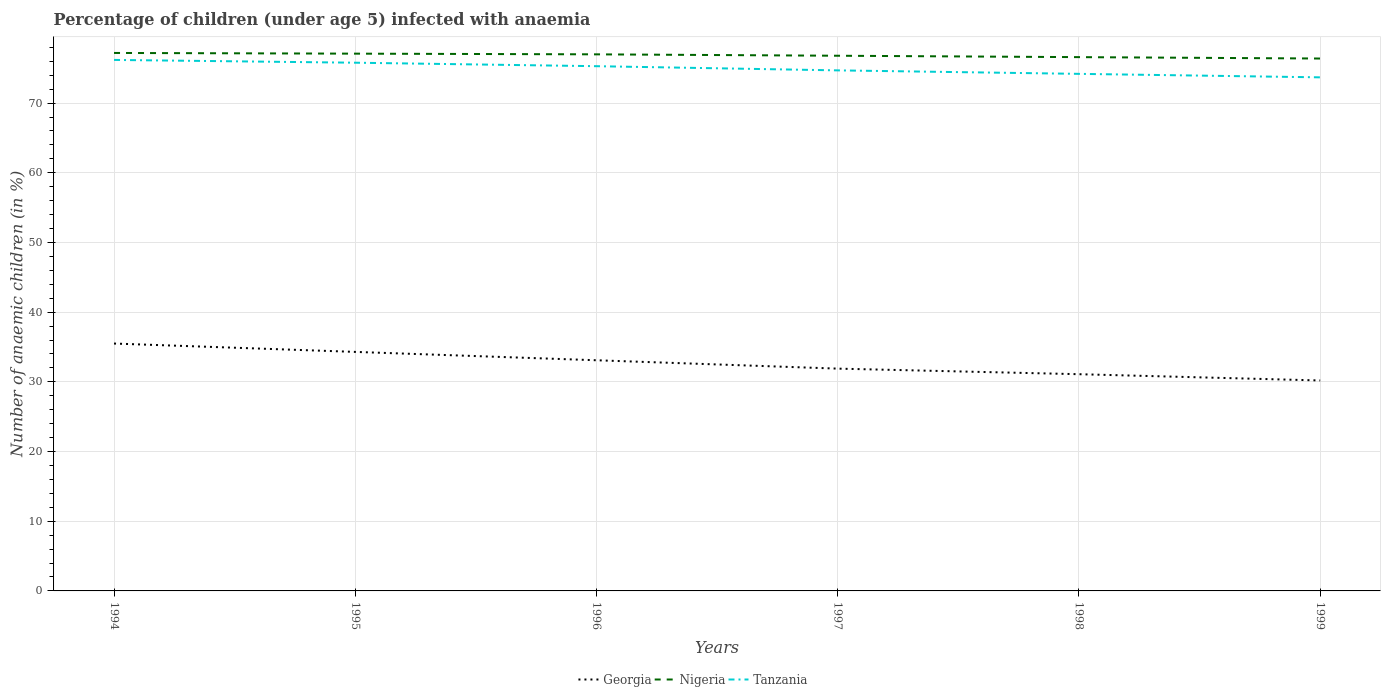How many different coloured lines are there?
Offer a very short reply. 3. Does the line corresponding to Nigeria intersect with the line corresponding to Georgia?
Your answer should be compact. No. Across all years, what is the maximum percentage of children infected with anaemia in in Nigeria?
Ensure brevity in your answer.  76.4. In which year was the percentage of children infected with anaemia in in Georgia maximum?
Make the answer very short. 1999. What is the total percentage of children infected with anaemia in in Nigeria in the graph?
Offer a terse response. 0.2. What is the difference between the highest and the second highest percentage of children infected with anaemia in in Nigeria?
Offer a very short reply. 0.8. What is the difference between the highest and the lowest percentage of children infected with anaemia in in Tanzania?
Offer a terse response. 3. How many lines are there?
Offer a terse response. 3. What is the difference between two consecutive major ticks on the Y-axis?
Your answer should be compact. 10. Are the values on the major ticks of Y-axis written in scientific E-notation?
Ensure brevity in your answer.  No. Where does the legend appear in the graph?
Make the answer very short. Bottom center. What is the title of the graph?
Provide a succinct answer. Percentage of children (under age 5) infected with anaemia. Does "Peru" appear as one of the legend labels in the graph?
Offer a very short reply. No. What is the label or title of the Y-axis?
Your response must be concise. Number of anaemic children (in %). What is the Number of anaemic children (in %) of Georgia in 1994?
Keep it short and to the point. 35.5. What is the Number of anaemic children (in %) of Nigeria in 1994?
Keep it short and to the point. 77.2. What is the Number of anaemic children (in %) of Tanzania in 1994?
Keep it short and to the point. 76.2. What is the Number of anaemic children (in %) in Georgia in 1995?
Your response must be concise. 34.3. What is the Number of anaemic children (in %) in Nigeria in 1995?
Give a very brief answer. 77.1. What is the Number of anaemic children (in %) in Tanzania in 1995?
Offer a very short reply. 75.8. What is the Number of anaemic children (in %) in Georgia in 1996?
Provide a short and direct response. 33.1. What is the Number of anaemic children (in %) of Nigeria in 1996?
Your answer should be compact. 77. What is the Number of anaemic children (in %) in Tanzania in 1996?
Your response must be concise. 75.3. What is the Number of anaemic children (in %) in Georgia in 1997?
Your answer should be very brief. 31.9. What is the Number of anaemic children (in %) of Nigeria in 1997?
Keep it short and to the point. 76.8. What is the Number of anaemic children (in %) in Tanzania in 1997?
Provide a short and direct response. 74.7. What is the Number of anaemic children (in %) in Georgia in 1998?
Make the answer very short. 31.1. What is the Number of anaemic children (in %) in Nigeria in 1998?
Make the answer very short. 76.6. What is the Number of anaemic children (in %) of Tanzania in 1998?
Provide a succinct answer. 74.2. What is the Number of anaemic children (in %) of Georgia in 1999?
Offer a very short reply. 30.2. What is the Number of anaemic children (in %) of Nigeria in 1999?
Provide a short and direct response. 76.4. What is the Number of anaemic children (in %) in Tanzania in 1999?
Your answer should be compact. 73.7. Across all years, what is the maximum Number of anaemic children (in %) of Georgia?
Make the answer very short. 35.5. Across all years, what is the maximum Number of anaemic children (in %) in Nigeria?
Offer a terse response. 77.2. Across all years, what is the maximum Number of anaemic children (in %) of Tanzania?
Give a very brief answer. 76.2. Across all years, what is the minimum Number of anaemic children (in %) of Georgia?
Your response must be concise. 30.2. Across all years, what is the minimum Number of anaemic children (in %) of Nigeria?
Make the answer very short. 76.4. Across all years, what is the minimum Number of anaemic children (in %) of Tanzania?
Offer a terse response. 73.7. What is the total Number of anaemic children (in %) of Georgia in the graph?
Make the answer very short. 196.1. What is the total Number of anaemic children (in %) of Nigeria in the graph?
Offer a very short reply. 461.1. What is the total Number of anaemic children (in %) in Tanzania in the graph?
Keep it short and to the point. 449.9. What is the difference between the Number of anaemic children (in %) of Georgia in 1994 and that in 1995?
Give a very brief answer. 1.2. What is the difference between the Number of anaemic children (in %) in Tanzania in 1994 and that in 1995?
Offer a terse response. 0.4. What is the difference between the Number of anaemic children (in %) of Georgia in 1994 and that in 1996?
Give a very brief answer. 2.4. What is the difference between the Number of anaemic children (in %) of Tanzania in 1994 and that in 1996?
Offer a terse response. 0.9. What is the difference between the Number of anaemic children (in %) in Nigeria in 1994 and that in 1998?
Provide a succinct answer. 0.6. What is the difference between the Number of anaemic children (in %) of Tanzania in 1994 and that in 1999?
Make the answer very short. 2.5. What is the difference between the Number of anaemic children (in %) of Nigeria in 1995 and that in 1996?
Ensure brevity in your answer.  0.1. What is the difference between the Number of anaemic children (in %) in Tanzania in 1995 and that in 1996?
Provide a succinct answer. 0.5. What is the difference between the Number of anaemic children (in %) in Tanzania in 1995 and that in 1997?
Your response must be concise. 1.1. What is the difference between the Number of anaemic children (in %) in Georgia in 1995 and that in 1998?
Give a very brief answer. 3.2. What is the difference between the Number of anaemic children (in %) of Georgia in 1995 and that in 1999?
Your answer should be very brief. 4.1. What is the difference between the Number of anaemic children (in %) in Nigeria in 1996 and that in 1997?
Give a very brief answer. 0.2. What is the difference between the Number of anaemic children (in %) of Tanzania in 1996 and that in 1997?
Offer a terse response. 0.6. What is the difference between the Number of anaemic children (in %) of Georgia in 1996 and that in 1998?
Provide a short and direct response. 2. What is the difference between the Number of anaemic children (in %) of Georgia in 1996 and that in 1999?
Your response must be concise. 2.9. What is the difference between the Number of anaemic children (in %) of Nigeria in 1996 and that in 1999?
Your answer should be very brief. 0.6. What is the difference between the Number of anaemic children (in %) in Tanzania in 1997 and that in 1998?
Make the answer very short. 0.5. What is the difference between the Number of anaemic children (in %) of Georgia in 1997 and that in 1999?
Offer a terse response. 1.7. What is the difference between the Number of anaemic children (in %) in Nigeria in 1997 and that in 1999?
Offer a terse response. 0.4. What is the difference between the Number of anaemic children (in %) of Tanzania in 1997 and that in 1999?
Your answer should be very brief. 1. What is the difference between the Number of anaemic children (in %) in Nigeria in 1998 and that in 1999?
Your answer should be compact. 0.2. What is the difference between the Number of anaemic children (in %) of Georgia in 1994 and the Number of anaemic children (in %) of Nigeria in 1995?
Offer a very short reply. -41.6. What is the difference between the Number of anaemic children (in %) of Georgia in 1994 and the Number of anaemic children (in %) of Tanzania in 1995?
Offer a very short reply. -40.3. What is the difference between the Number of anaemic children (in %) in Nigeria in 1994 and the Number of anaemic children (in %) in Tanzania in 1995?
Make the answer very short. 1.4. What is the difference between the Number of anaemic children (in %) of Georgia in 1994 and the Number of anaemic children (in %) of Nigeria in 1996?
Provide a short and direct response. -41.5. What is the difference between the Number of anaemic children (in %) in Georgia in 1994 and the Number of anaemic children (in %) in Tanzania in 1996?
Ensure brevity in your answer.  -39.8. What is the difference between the Number of anaemic children (in %) in Nigeria in 1994 and the Number of anaemic children (in %) in Tanzania in 1996?
Offer a terse response. 1.9. What is the difference between the Number of anaemic children (in %) in Georgia in 1994 and the Number of anaemic children (in %) in Nigeria in 1997?
Provide a short and direct response. -41.3. What is the difference between the Number of anaemic children (in %) of Georgia in 1994 and the Number of anaemic children (in %) of Tanzania in 1997?
Make the answer very short. -39.2. What is the difference between the Number of anaemic children (in %) in Nigeria in 1994 and the Number of anaemic children (in %) in Tanzania in 1997?
Your answer should be very brief. 2.5. What is the difference between the Number of anaemic children (in %) of Georgia in 1994 and the Number of anaemic children (in %) of Nigeria in 1998?
Your answer should be compact. -41.1. What is the difference between the Number of anaemic children (in %) in Georgia in 1994 and the Number of anaemic children (in %) in Tanzania in 1998?
Your response must be concise. -38.7. What is the difference between the Number of anaemic children (in %) of Georgia in 1994 and the Number of anaemic children (in %) of Nigeria in 1999?
Offer a terse response. -40.9. What is the difference between the Number of anaemic children (in %) of Georgia in 1994 and the Number of anaemic children (in %) of Tanzania in 1999?
Keep it short and to the point. -38.2. What is the difference between the Number of anaemic children (in %) in Georgia in 1995 and the Number of anaemic children (in %) in Nigeria in 1996?
Provide a short and direct response. -42.7. What is the difference between the Number of anaemic children (in %) of Georgia in 1995 and the Number of anaemic children (in %) of Tanzania in 1996?
Offer a terse response. -41. What is the difference between the Number of anaemic children (in %) in Georgia in 1995 and the Number of anaemic children (in %) in Nigeria in 1997?
Ensure brevity in your answer.  -42.5. What is the difference between the Number of anaemic children (in %) of Georgia in 1995 and the Number of anaemic children (in %) of Tanzania in 1997?
Your answer should be very brief. -40.4. What is the difference between the Number of anaemic children (in %) of Nigeria in 1995 and the Number of anaemic children (in %) of Tanzania in 1997?
Make the answer very short. 2.4. What is the difference between the Number of anaemic children (in %) of Georgia in 1995 and the Number of anaemic children (in %) of Nigeria in 1998?
Give a very brief answer. -42.3. What is the difference between the Number of anaemic children (in %) of Georgia in 1995 and the Number of anaemic children (in %) of Tanzania in 1998?
Your answer should be very brief. -39.9. What is the difference between the Number of anaemic children (in %) in Georgia in 1995 and the Number of anaemic children (in %) in Nigeria in 1999?
Offer a very short reply. -42.1. What is the difference between the Number of anaemic children (in %) of Georgia in 1995 and the Number of anaemic children (in %) of Tanzania in 1999?
Your response must be concise. -39.4. What is the difference between the Number of anaemic children (in %) of Georgia in 1996 and the Number of anaemic children (in %) of Nigeria in 1997?
Provide a short and direct response. -43.7. What is the difference between the Number of anaemic children (in %) in Georgia in 1996 and the Number of anaemic children (in %) in Tanzania in 1997?
Keep it short and to the point. -41.6. What is the difference between the Number of anaemic children (in %) of Georgia in 1996 and the Number of anaemic children (in %) of Nigeria in 1998?
Your answer should be compact. -43.5. What is the difference between the Number of anaemic children (in %) in Georgia in 1996 and the Number of anaemic children (in %) in Tanzania in 1998?
Provide a succinct answer. -41.1. What is the difference between the Number of anaemic children (in %) in Georgia in 1996 and the Number of anaemic children (in %) in Nigeria in 1999?
Your response must be concise. -43.3. What is the difference between the Number of anaemic children (in %) in Georgia in 1996 and the Number of anaemic children (in %) in Tanzania in 1999?
Your response must be concise. -40.6. What is the difference between the Number of anaemic children (in %) of Georgia in 1997 and the Number of anaemic children (in %) of Nigeria in 1998?
Provide a short and direct response. -44.7. What is the difference between the Number of anaemic children (in %) of Georgia in 1997 and the Number of anaemic children (in %) of Tanzania in 1998?
Give a very brief answer. -42.3. What is the difference between the Number of anaemic children (in %) in Georgia in 1997 and the Number of anaemic children (in %) in Nigeria in 1999?
Offer a terse response. -44.5. What is the difference between the Number of anaemic children (in %) of Georgia in 1997 and the Number of anaemic children (in %) of Tanzania in 1999?
Make the answer very short. -41.8. What is the difference between the Number of anaemic children (in %) of Nigeria in 1997 and the Number of anaemic children (in %) of Tanzania in 1999?
Provide a succinct answer. 3.1. What is the difference between the Number of anaemic children (in %) of Georgia in 1998 and the Number of anaemic children (in %) of Nigeria in 1999?
Your answer should be very brief. -45.3. What is the difference between the Number of anaemic children (in %) of Georgia in 1998 and the Number of anaemic children (in %) of Tanzania in 1999?
Keep it short and to the point. -42.6. What is the difference between the Number of anaemic children (in %) in Nigeria in 1998 and the Number of anaemic children (in %) in Tanzania in 1999?
Provide a succinct answer. 2.9. What is the average Number of anaemic children (in %) of Georgia per year?
Offer a terse response. 32.68. What is the average Number of anaemic children (in %) of Nigeria per year?
Offer a terse response. 76.85. What is the average Number of anaemic children (in %) in Tanzania per year?
Your answer should be very brief. 74.98. In the year 1994, what is the difference between the Number of anaemic children (in %) in Georgia and Number of anaemic children (in %) in Nigeria?
Make the answer very short. -41.7. In the year 1994, what is the difference between the Number of anaemic children (in %) of Georgia and Number of anaemic children (in %) of Tanzania?
Your answer should be compact. -40.7. In the year 1995, what is the difference between the Number of anaemic children (in %) in Georgia and Number of anaemic children (in %) in Nigeria?
Your response must be concise. -42.8. In the year 1995, what is the difference between the Number of anaemic children (in %) in Georgia and Number of anaemic children (in %) in Tanzania?
Your response must be concise. -41.5. In the year 1995, what is the difference between the Number of anaemic children (in %) in Nigeria and Number of anaemic children (in %) in Tanzania?
Your answer should be compact. 1.3. In the year 1996, what is the difference between the Number of anaemic children (in %) of Georgia and Number of anaemic children (in %) of Nigeria?
Your response must be concise. -43.9. In the year 1996, what is the difference between the Number of anaemic children (in %) of Georgia and Number of anaemic children (in %) of Tanzania?
Offer a very short reply. -42.2. In the year 1997, what is the difference between the Number of anaemic children (in %) in Georgia and Number of anaemic children (in %) in Nigeria?
Offer a terse response. -44.9. In the year 1997, what is the difference between the Number of anaemic children (in %) of Georgia and Number of anaemic children (in %) of Tanzania?
Provide a short and direct response. -42.8. In the year 1998, what is the difference between the Number of anaemic children (in %) of Georgia and Number of anaemic children (in %) of Nigeria?
Provide a short and direct response. -45.5. In the year 1998, what is the difference between the Number of anaemic children (in %) in Georgia and Number of anaemic children (in %) in Tanzania?
Your answer should be very brief. -43.1. In the year 1999, what is the difference between the Number of anaemic children (in %) of Georgia and Number of anaemic children (in %) of Nigeria?
Your response must be concise. -46.2. In the year 1999, what is the difference between the Number of anaemic children (in %) of Georgia and Number of anaemic children (in %) of Tanzania?
Give a very brief answer. -43.5. What is the ratio of the Number of anaemic children (in %) of Georgia in 1994 to that in 1995?
Provide a succinct answer. 1.03. What is the ratio of the Number of anaemic children (in %) of Nigeria in 1994 to that in 1995?
Ensure brevity in your answer.  1. What is the ratio of the Number of anaemic children (in %) in Tanzania in 1994 to that in 1995?
Ensure brevity in your answer.  1.01. What is the ratio of the Number of anaemic children (in %) of Georgia in 1994 to that in 1996?
Offer a terse response. 1.07. What is the ratio of the Number of anaemic children (in %) in Georgia in 1994 to that in 1997?
Your response must be concise. 1.11. What is the ratio of the Number of anaemic children (in %) of Nigeria in 1994 to that in 1997?
Keep it short and to the point. 1.01. What is the ratio of the Number of anaemic children (in %) of Tanzania in 1994 to that in 1997?
Your answer should be very brief. 1.02. What is the ratio of the Number of anaemic children (in %) of Georgia in 1994 to that in 1998?
Provide a succinct answer. 1.14. What is the ratio of the Number of anaemic children (in %) in Nigeria in 1994 to that in 1998?
Make the answer very short. 1.01. What is the ratio of the Number of anaemic children (in %) in Tanzania in 1994 to that in 1998?
Your response must be concise. 1.03. What is the ratio of the Number of anaemic children (in %) in Georgia in 1994 to that in 1999?
Your response must be concise. 1.18. What is the ratio of the Number of anaemic children (in %) of Nigeria in 1994 to that in 1999?
Keep it short and to the point. 1.01. What is the ratio of the Number of anaemic children (in %) in Tanzania in 1994 to that in 1999?
Keep it short and to the point. 1.03. What is the ratio of the Number of anaemic children (in %) of Georgia in 1995 to that in 1996?
Your answer should be compact. 1.04. What is the ratio of the Number of anaemic children (in %) in Nigeria in 1995 to that in 1996?
Your response must be concise. 1. What is the ratio of the Number of anaemic children (in %) of Tanzania in 1995 to that in 1996?
Offer a terse response. 1.01. What is the ratio of the Number of anaemic children (in %) in Georgia in 1995 to that in 1997?
Give a very brief answer. 1.08. What is the ratio of the Number of anaemic children (in %) in Tanzania in 1995 to that in 1997?
Provide a succinct answer. 1.01. What is the ratio of the Number of anaemic children (in %) in Georgia in 1995 to that in 1998?
Offer a terse response. 1.1. What is the ratio of the Number of anaemic children (in %) of Nigeria in 1995 to that in 1998?
Make the answer very short. 1.01. What is the ratio of the Number of anaemic children (in %) in Tanzania in 1995 to that in 1998?
Make the answer very short. 1.02. What is the ratio of the Number of anaemic children (in %) of Georgia in 1995 to that in 1999?
Your answer should be compact. 1.14. What is the ratio of the Number of anaemic children (in %) of Nigeria in 1995 to that in 1999?
Provide a succinct answer. 1.01. What is the ratio of the Number of anaemic children (in %) of Tanzania in 1995 to that in 1999?
Provide a succinct answer. 1.03. What is the ratio of the Number of anaemic children (in %) of Georgia in 1996 to that in 1997?
Ensure brevity in your answer.  1.04. What is the ratio of the Number of anaemic children (in %) of Nigeria in 1996 to that in 1997?
Make the answer very short. 1. What is the ratio of the Number of anaemic children (in %) of Georgia in 1996 to that in 1998?
Offer a terse response. 1.06. What is the ratio of the Number of anaemic children (in %) in Nigeria in 1996 to that in 1998?
Your response must be concise. 1.01. What is the ratio of the Number of anaemic children (in %) of Tanzania in 1996 to that in 1998?
Make the answer very short. 1.01. What is the ratio of the Number of anaemic children (in %) of Georgia in 1996 to that in 1999?
Ensure brevity in your answer.  1.1. What is the ratio of the Number of anaemic children (in %) of Nigeria in 1996 to that in 1999?
Give a very brief answer. 1.01. What is the ratio of the Number of anaemic children (in %) of Tanzania in 1996 to that in 1999?
Keep it short and to the point. 1.02. What is the ratio of the Number of anaemic children (in %) of Georgia in 1997 to that in 1998?
Your response must be concise. 1.03. What is the ratio of the Number of anaemic children (in %) of Tanzania in 1997 to that in 1998?
Make the answer very short. 1.01. What is the ratio of the Number of anaemic children (in %) of Georgia in 1997 to that in 1999?
Offer a very short reply. 1.06. What is the ratio of the Number of anaemic children (in %) in Tanzania in 1997 to that in 1999?
Ensure brevity in your answer.  1.01. What is the ratio of the Number of anaemic children (in %) in Georgia in 1998 to that in 1999?
Ensure brevity in your answer.  1.03. What is the ratio of the Number of anaemic children (in %) of Tanzania in 1998 to that in 1999?
Your answer should be compact. 1.01. What is the difference between the highest and the lowest Number of anaemic children (in %) of Georgia?
Give a very brief answer. 5.3. What is the difference between the highest and the lowest Number of anaemic children (in %) in Nigeria?
Offer a very short reply. 0.8. What is the difference between the highest and the lowest Number of anaemic children (in %) in Tanzania?
Give a very brief answer. 2.5. 